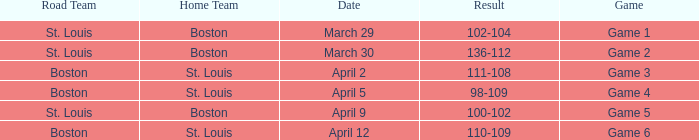On what Date is Game 3 with Boston Road Team? April 2. 